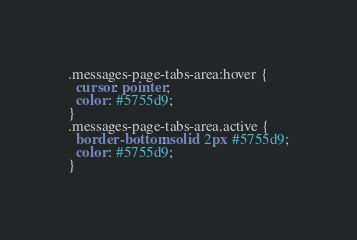Convert code to text. <code><loc_0><loc_0><loc_500><loc_500><_CSS_>.messages-page-tabs-area:hover {
  cursor: pointer;
  color: #5755d9;
}
.messages-page-tabs-area.active {
  border-bottom: solid 2px #5755d9;
  color: #5755d9;
}</code> 